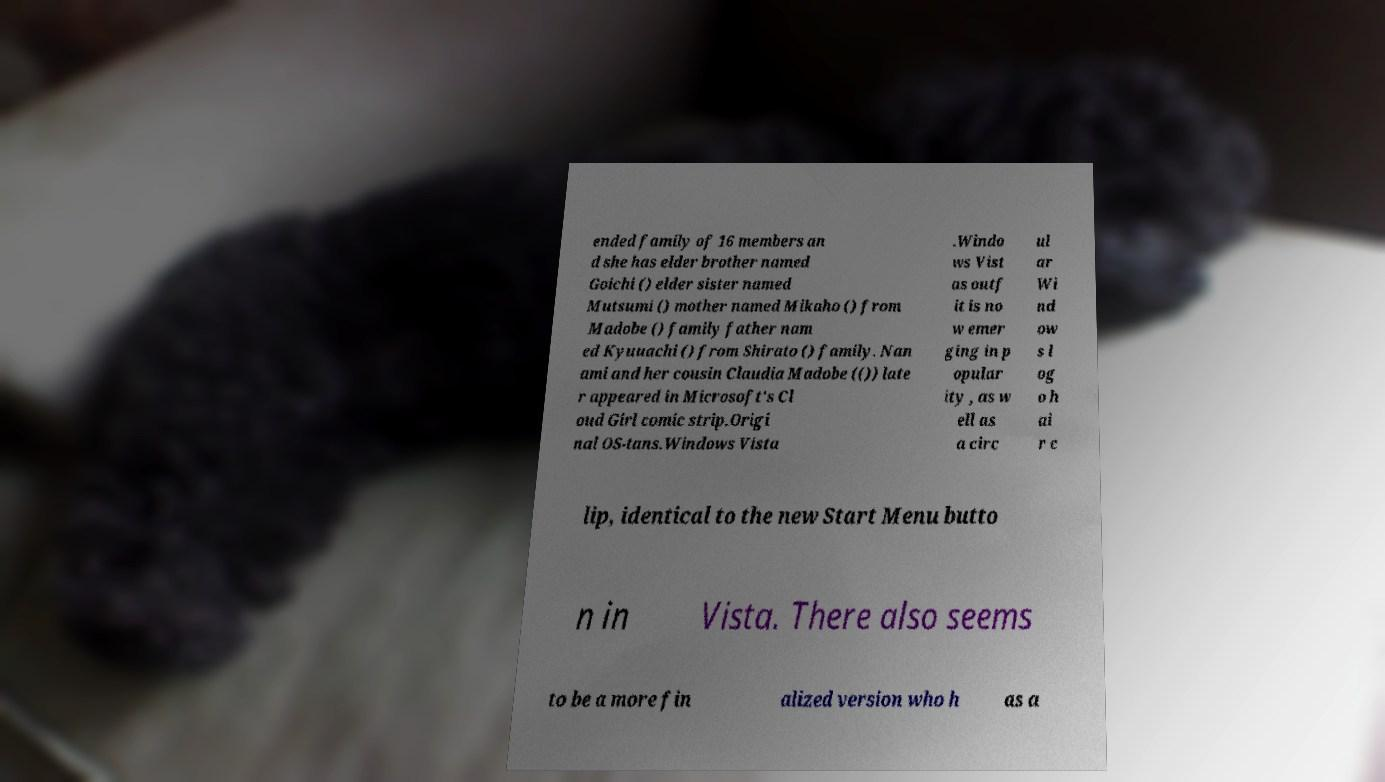Could you extract and type out the text from this image? ended family of 16 members an d she has elder brother named Goichi () elder sister named Mutsumi () mother named Mikaho () from Madobe () family father nam ed Kyuuachi () from Shirato () family. Nan ami and her cousin Claudia Madobe (()) late r appeared in Microsoft's Cl oud Girl comic strip.Origi nal OS-tans.Windows Vista .Windo ws Vist as outf it is no w emer ging in p opular ity , as w ell as a circ ul ar Wi nd ow s l og o h ai r c lip, identical to the new Start Menu butto n in Vista. There also seems to be a more fin alized version who h as a 